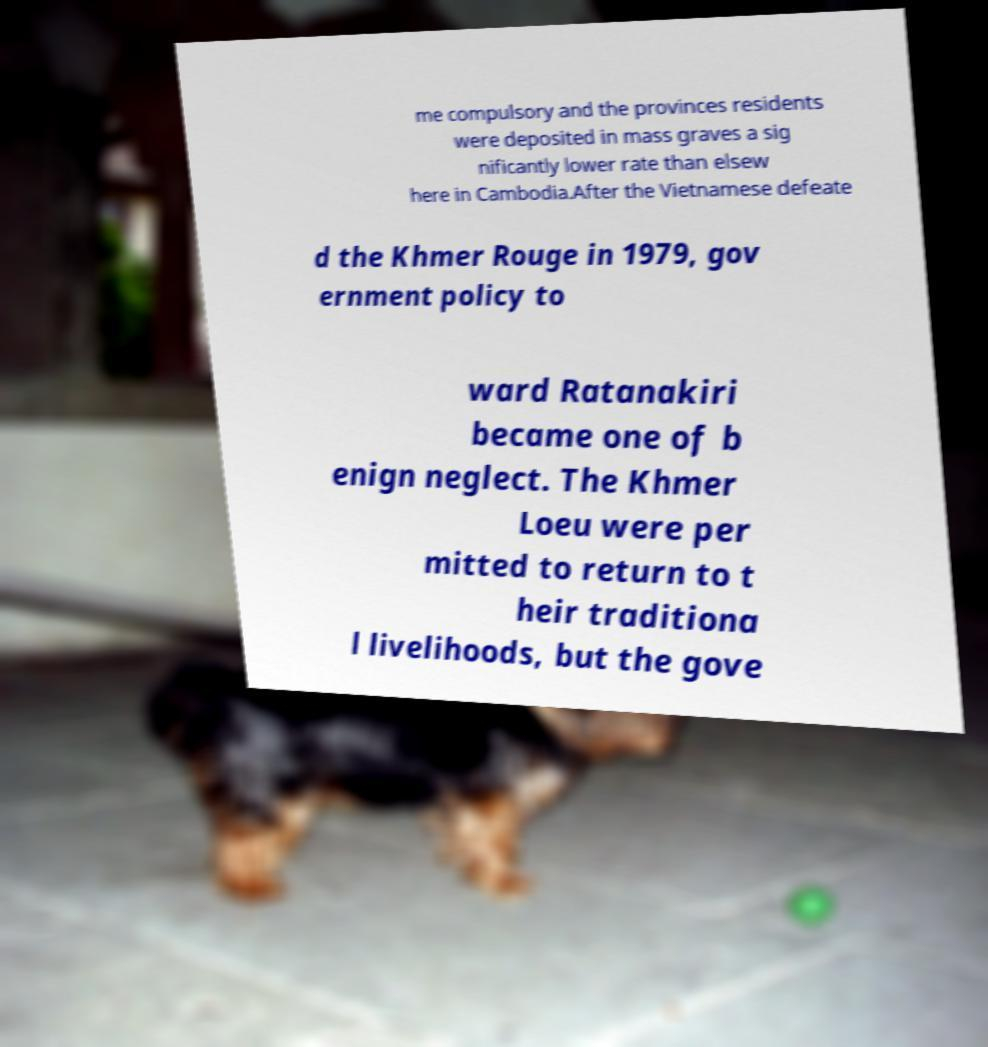Can you accurately transcribe the text from the provided image for me? me compulsory and the provinces residents were deposited in mass graves a sig nificantly lower rate than elsew here in Cambodia.After the Vietnamese defeate d the Khmer Rouge in 1979, gov ernment policy to ward Ratanakiri became one of b enign neglect. The Khmer Loeu were per mitted to return to t heir traditiona l livelihoods, but the gove 